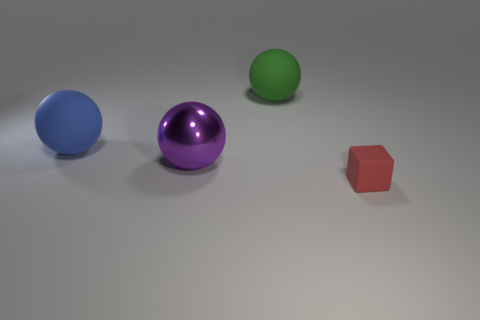What material is the sphere in front of the big thing to the left of the big metal sphere made of?
Keep it short and to the point. Metal. Are there an equal number of matte things that are on the left side of the green matte object and big purple things?
Provide a short and direct response. Yes. What size is the thing that is both to the right of the big purple metallic object and on the left side of the tiny cube?
Give a very brief answer. Large. The big thing in front of the object that is to the left of the purple metallic object is what color?
Give a very brief answer. Purple. How many brown objects are either metallic objects or big spheres?
Ensure brevity in your answer.  0. What is the color of the object that is both right of the purple ball and behind the large metallic thing?
Give a very brief answer. Green. What number of big things are spheres or gray matte things?
Make the answer very short. 3. There is a green object that is the same shape as the blue rubber thing; what size is it?
Ensure brevity in your answer.  Large. What is the shape of the metal thing?
Provide a succinct answer. Sphere. Do the red thing and the thing that is on the left side of the purple ball have the same material?
Offer a very short reply. Yes. 